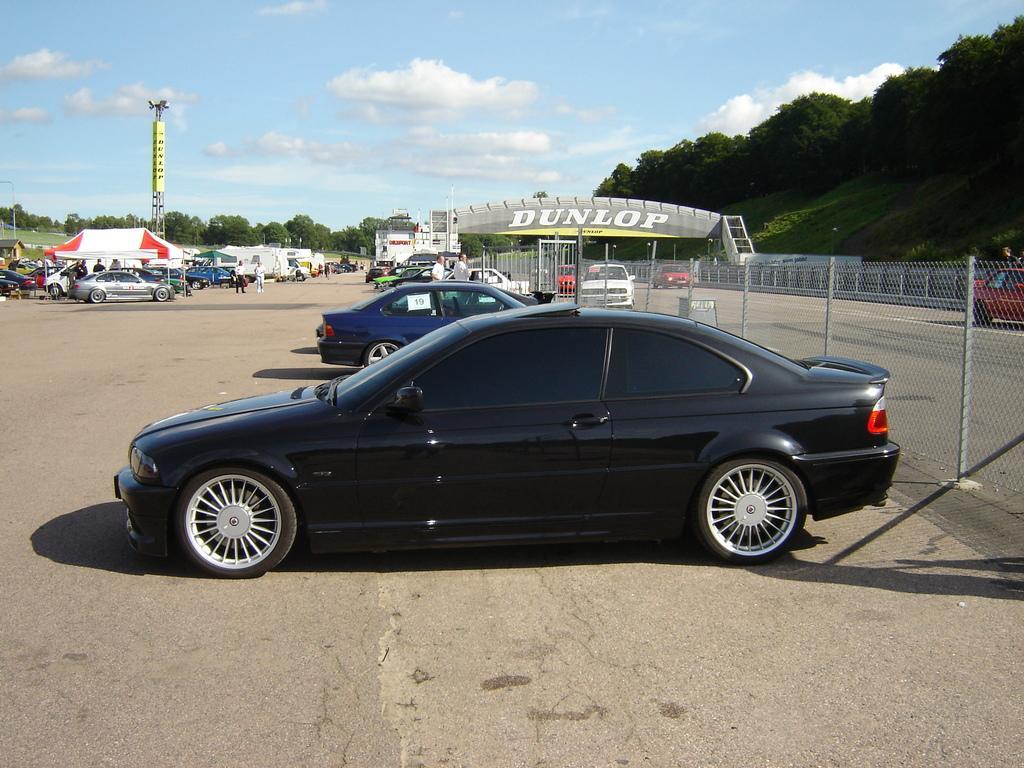Describe this image in one or two sentences. In this picture I can see vehicles on the road, there are group of people standing, there is a canopy tent and a house, there are poles, lights, there is an arch, there is fence, there are trees, and in the background there is the sky. 